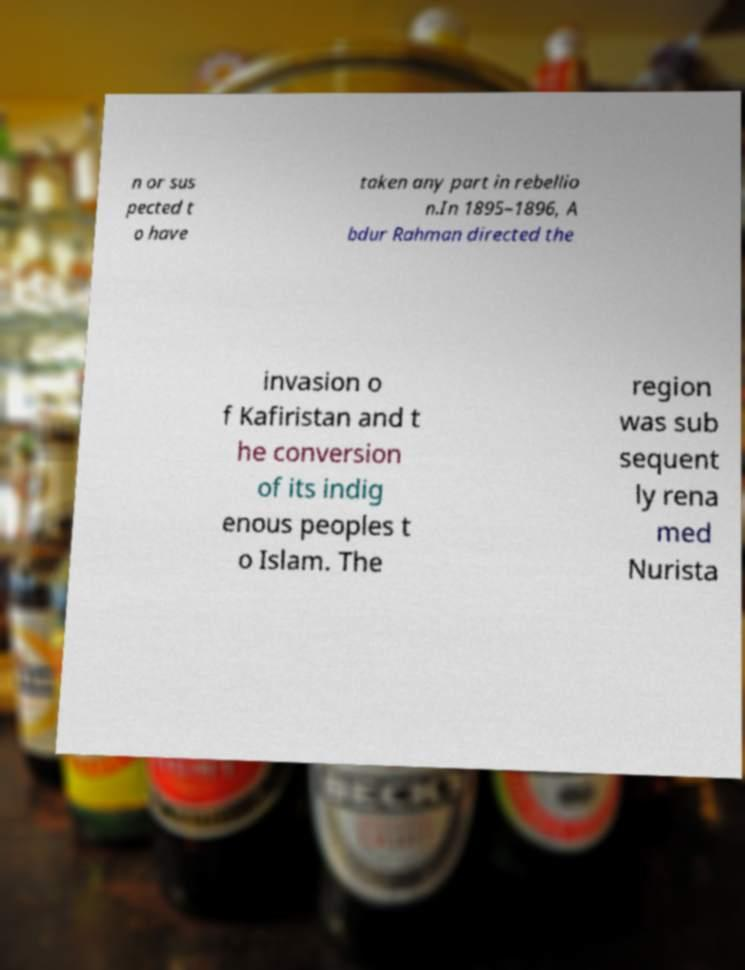What messages or text are displayed in this image? I need them in a readable, typed format. n or sus pected t o have taken any part in rebellio n.In 1895–1896, A bdur Rahman directed the invasion o f Kafiristan and t he conversion of its indig enous peoples t o Islam. The region was sub sequent ly rena med Nurista 